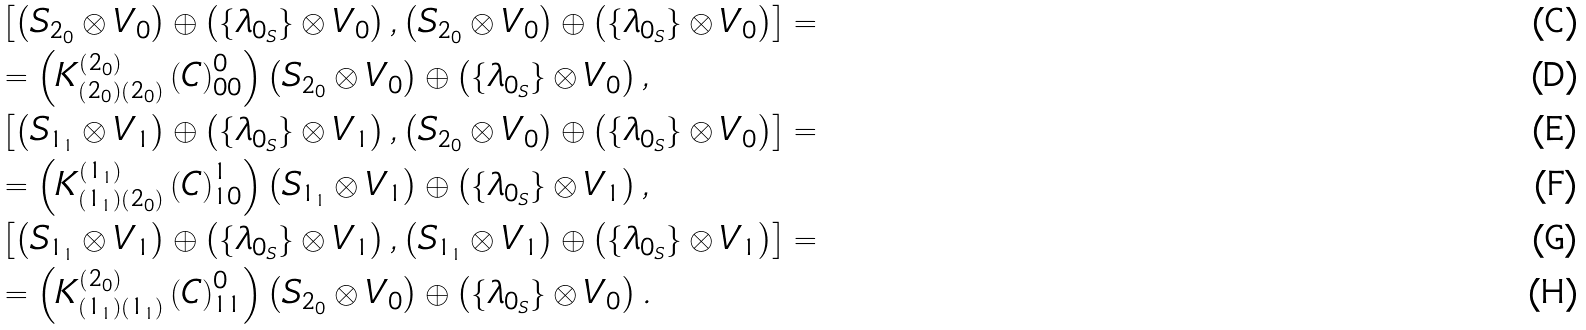<formula> <loc_0><loc_0><loc_500><loc_500>& \left [ \left ( S _ { 2 _ { 0 } } \otimes V _ { 0 } \right ) \oplus \left ( \{ \lambda _ { 0 _ { S } } \} \otimes V _ { 0 } \right ) , \left ( S _ { 2 _ { 0 } } \otimes V _ { 0 } \right ) \oplus \left ( \{ \lambda _ { 0 _ { S } } \} \otimes V _ { 0 } \right ) \right ] = \\ & = \left ( K _ { \left ( 2 _ { 0 } \right ) \left ( 2 _ { 0 } \right ) } ^ { \left ( 2 _ { 0 } \right ) } \left ( C \right ) _ { 0 0 } ^ { 0 } \right ) \left ( S _ { 2 _ { 0 } } \otimes V _ { 0 } \right ) \oplus \left ( \{ \lambda _ { 0 _ { S } } \} \otimes V _ { 0 } \right ) , \\ & \left [ \left ( S _ { 1 _ { 1 } } \otimes V _ { 1 } \right ) \oplus \left ( \{ \lambda _ { 0 _ { S } } \} \otimes V _ { 1 } \right ) , \left ( S _ { 2 _ { 0 } } \otimes V _ { 0 } \right ) \oplus \left ( \{ \lambda _ { 0 _ { S } } \} \otimes V _ { 0 } \right ) \right ] = \\ & = \left ( K _ { \left ( 1 _ { 1 } \right ) \left ( 2 _ { 0 } \right ) } ^ { \left ( 1 _ { 1 } \right ) } \left ( C \right ) _ { 1 0 } ^ { 1 } \right ) \left ( S _ { 1 _ { 1 } } \otimes V _ { 1 } \right ) \oplus \left ( \{ \lambda _ { 0 _ { S } } \} \otimes V _ { 1 } \right ) , \\ & \left [ \left ( S _ { 1 _ { 1 } } \otimes V _ { 1 } \right ) \oplus \left ( \{ \lambda _ { 0 _ { S } } \} \otimes V _ { 1 } \right ) , \left ( S _ { 1 _ { 1 } } \otimes V _ { 1 } \right ) \oplus \left ( \{ \lambda _ { 0 _ { S } } \} \otimes V _ { 1 } \right ) \right ] = \\ & = \left ( K _ { \left ( 1 _ { 1 } \right ) \left ( 1 _ { 1 } \right ) } ^ { \left ( 2 _ { 0 } \right ) } \left ( C \right ) _ { 1 1 } ^ { 0 } \right ) \left ( S _ { 2 _ { 0 } } \otimes V _ { 0 } \right ) \oplus \left ( \{ \lambda _ { 0 _ { S } } \} \otimes V _ { 0 } \right ) .</formula> 